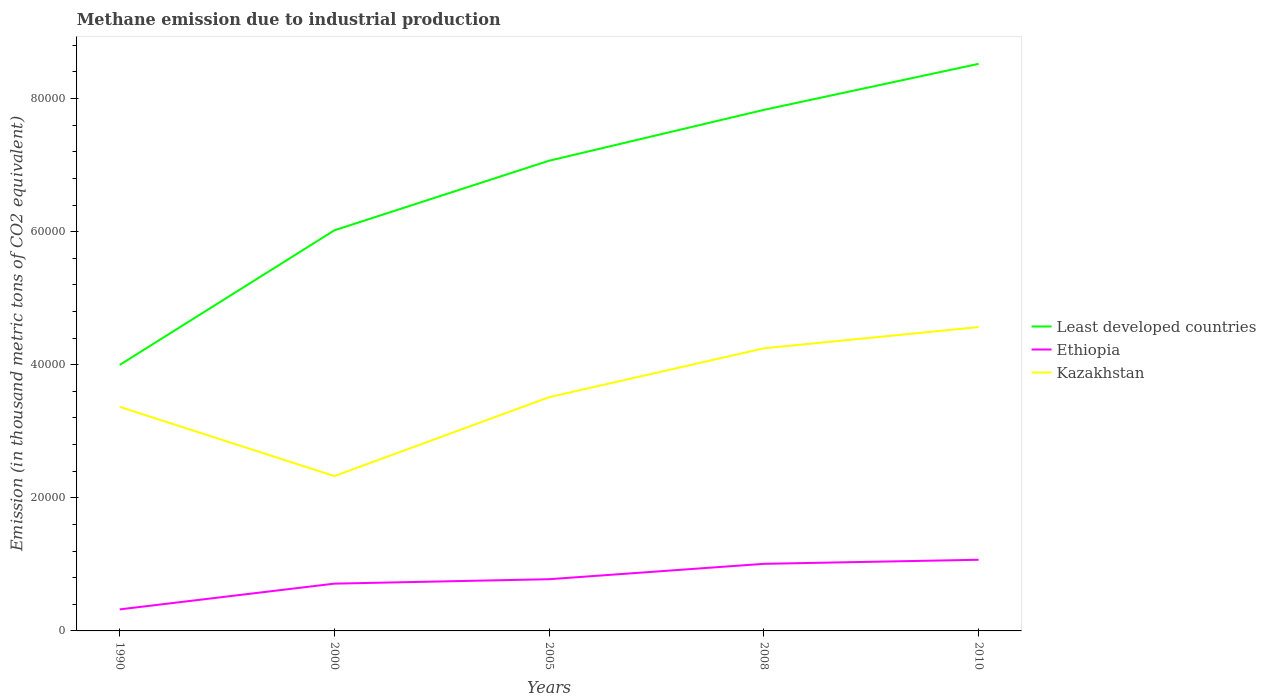How many different coloured lines are there?
Provide a succinct answer. 3. Across all years, what is the maximum amount of methane emitted in Kazakhstan?
Offer a terse response. 2.33e+04. In which year was the amount of methane emitted in Kazakhstan maximum?
Make the answer very short. 2000. What is the total amount of methane emitted in Kazakhstan in the graph?
Your response must be concise. -1456.8. What is the difference between the highest and the second highest amount of methane emitted in Least developed countries?
Provide a succinct answer. 4.52e+04. What is the difference between the highest and the lowest amount of methane emitted in Ethiopia?
Ensure brevity in your answer.  2. Are the values on the major ticks of Y-axis written in scientific E-notation?
Make the answer very short. No. Does the graph contain any zero values?
Keep it short and to the point. No. Does the graph contain grids?
Provide a succinct answer. No. How are the legend labels stacked?
Give a very brief answer. Vertical. What is the title of the graph?
Provide a succinct answer. Methane emission due to industrial production. What is the label or title of the Y-axis?
Make the answer very short. Emission (in thousand metric tons of CO2 equivalent). What is the Emission (in thousand metric tons of CO2 equivalent) of Least developed countries in 1990?
Offer a terse response. 4.00e+04. What is the Emission (in thousand metric tons of CO2 equivalent) of Ethiopia in 1990?
Give a very brief answer. 3236. What is the Emission (in thousand metric tons of CO2 equivalent) in Kazakhstan in 1990?
Provide a short and direct response. 3.37e+04. What is the Emission (in thousand metric tons of CO2 equivalent) of Least developed countries in 2000?
Provide a short and direct response. 6.02e+04. What is the Emission (in thousand metric tons of CO2 equivalent) of Ethiopia in 2000?
Ensure brevity in your answer.  7106. What is the Emission (in thousand metric tons of CO2 equivalent) of Kazakhstan in 2000?
Make the answer very short. 2.33e+04. What is the Emission (in thousand metric tons of CO2 equivalent) in Least developed countries in 2005?
Keep it short and to the point. 7.07e+04. What is the Emission (in thousand metric tons of CO2 equivalent) in Ethiopia in 2005?
Your answer should be very brief. 7772.1. What is the Emission (in thousand metric tons of CO2 equivalent) of Kazakhstan in 2005?
Your answer should be compact. 3.51e+04. What is the Emission (in thousand metric tons of CO2 equivalent) of Least developed countries in 2008?
Make the answer very short. 7.83e+04. What is the Emission (in thousand metric tons of CO2 equivalent) in Ethiopia in 2008?
Offer a terse response. 1.01e+04. What is the Emission (in thousand metric tons of CO2 equivalent) of Kazakhstan in 2008?
Offer a terse response. 4.25e+04. What is the Emission (in thousand metric tons of CO2 equivalent) of Least developed countries in 2010?
Your answer should be very brief. 8.52e+04. What is the Emission (in thousand metric tons of CO2 equivalent) of Ethiopia in 2010?
Provide a succinct answer. 1.07e+04. What is the Emission (in thousand metric tons of CO2 equivalent) of Kazakhstan in 2010?
Make the answer very short. 4.57e+04. Across all years, what is the maximum Emission (in thousand metric tons of CO2 equivalent) of Least developed countries?
Offer a very short reply. 8.52e+04. Across all years, what is the maximum Emission (in thousand metric tons of CO2 equivalent) of Ethiopia?
Offer a terse response. 1.07e+04. Across all years, what is the maximum Emission (in thousand metric tons of CO2 equivalent) in Kazakhstan?
Offer a terse response. 4.57e+04. Across all years, what is the minimum Emission (in thousand metric tons of CO2 equivalent) in Least developed countries?
Keep it short and to the point. 4.00e+04. Across all years, what is the minimum Emission (in thousand metric tons of CO2 equivalent) of Ethiopia?
Make the answer very short. 3236. Across all years, what is the minimum Emission (in thousand metric tons of CO2 equivalent) in Kazakhstan?
Offer a terse response. 2.33e+04. What is the total Emission (in thousand metric tons of CO2 equivalent) in Least developed countries in the graph?
Keep it short and to the point. 3.34e+05. What is the total Emission (in thousand metric tons of CO2 equivalent) in Ethiopia in the graph?
Keep it short and to the point. 3.89e+04. What is the total Emission (in thousand metric tons of CO2 equivalent) of Kazakhstan in the graph?
Your answer should be compact. 1.80e+05. What is the difference between the Emission (in thousand metric tons of CO2 equivalent) in Least developed countries in 1990 and that in 2000?
Your answer should be compact. -2.02e+04. What is the difference between the Emission (in thousand metric tons of CO2 equivalent) of Ethiopia in 1990 and that in 2000?
Offer a very short reply. -3870. What is the difference between the Emission (in thousand metric tons of CO2 equivalent) in Kazakhstan in 1990 and that in 2000?
Make the answer very short. 1.04e+04. What is the difference between the Emission (in thousand metric tons of CO2 equivalent) of Least developed countries in 1990 and that in 2005?
Your response must be concise. -3.07e+04. What is the difference between the Emission (in thousand metric tons of CO2 equivalent) of Ethiopia in 1990 and that in 2005?
Provide a short and direct response. -4536.1. What is the difference between the Emission (in thousand metric tons of CO2 equivalent) of Kazakhstan in 1990 and that in 2005?
Your response must be concise. -1456.8. What is the difference between the Emission (in thousand metric tons of CO2 equivalent) of Least developed countries in 1990 and that in 2008?
Give a very brief answer. -3.83e+04. What is the difference between the Emission (in thousand metric tons of CO2 equivalent) of Ethiopia in 1990 and that in 2008?
Keep it short and to the point. -6846.3. What is the difference between the Emission (in thousand metric tons of CO2 equivalent) in Kazakhstan in 1990 and that in 2008?
Offer a terse response. -8797.8. What is the difference between the Emission (in thousand metric tons of CO2 equivalent) in Least developed countries in 1990 and that in 2010?
Provide a succinct answer. -4.52e+04. What is the difference between the Emission (in thousand metric tons of CO2 equivalent) in Ethiopia in 1990 and that in 2010?
Your answer should be very brief. -7457. What is the difference between the Emission (in thousand metric tons of CO2 equivalent) in Kazakhstan in 1990 and that in 2010?
Keep it short and to the point. -1.20e+04. What is the difference between the Emission (in thousand metric tons of CO2 equivalent) in Least developed countries in 2000 and that in 2005?
Offer a terse response. -1.05e+04. What is the difference between the Emission (in thousand metric tons of CO2 equivalent) of Ethiopia in 2000 and that in 2005?
Ensure brevity in your answer.  -666.1. What is the difference between the Emission (in thousand metric tons of CO2 equivalent) in Kazakhstan in 2000 and that in 2005?
Your answer should be compact. -1.19e+04. What is the difference between the Emission (in thousand metric tons of CO2 equivalent) of Least developed countries in 2000 and that in 2008?
Your answer should be compact. -1.81e+04. What is the difference between the Emission (in thousand metric tons of CO2 equivalent) of Ethiopia in 2000 and that in 2008?
Ensure brevity in your answer.  -2976.3. What is the difference between the Emission (in thousand metric tons of CO2 equivalent) in Kazakhstan in 2000 and that in 2008?
Offer a very short reply. -1.92e+04. What is the difference between the Emission (in thousand metric tons of CO2 equivalent) in Least developed countries in 2000 and that in 2010?
Provide a short and direct response. -2.50e+04. What is the difference between the Emission (in thousand metric tons of CO2 equivalent) in Ethiopia in 2000 and that in 2010?
Provide a succinct answer. -3587. What is the difference between the Emission (in thousand metric tons of CO2 equivalent) in Kazakhstan in 2000 and that in 2010?
Offer a very short reply. -2.24e+04. What is the difference between the Emission (in thousand metric tons of CO2 equivalent) in Least developed countries in 2005 and that in 2008?
Offer a terse response. -7639.7. What is the difference between the Emission (in thousand metric tons of CO2 equivalent) in Ethiopia in 2005 and that in 2008?
Provide a succinct answer. -2310.2. What is the difference between the Emission (in thousand metric tons of CO2 equivalent) of Kazakhstan in 2005 and that in 2008?
Make the answer very short. -7341. What is the difference between the Emission (in thousand metric tons of CO2 equivalent) of Least developed countries in 2005 and that in 2010?
Your answer should be very brief. -1.46e+04. What is the difference between the Emission (in thousand metric tons of CO2 equivalent) of Ethiopia in 2005 and that in 2010?
Offer a terse response. -2920.9. What is the difference between the Emission (in thousand metric tons of CO2 equivalent) in Kazakhstan in 2005 and that in 2010?
Provide a succinct answer. -1.05e+04. What is the difference between the Emission (in thousand metric tons of CO2 equivalent) of Least developed countries in 2008 and that in 2010?
Your answer should be very brief. -6916.6. What is the difference between the Emission (in thousand metric tons of CO2 equivalent) of Ethiopia in 2008 and that in 2010?
Provide a short and direct response. -610.7. What is the difference between the Emission (in thousand metric tons of CO2 equivalent) of Kazakhstan in 2008 and that in 2010?
Your response must be concise. -3195. What is the difference between the Emission (in thousand metric tons of CO2 equivalent) of Least developed countries in 1990 and the Emission (in thousand metric tons of CO2 equivalent) of Ethiopia in 2000?
Your answer should be very brief. 3.29e+04. What is the difference between the Emission (in thousand metric tons of CO2 equivalent) of Least developed countries in 1990 and the Emission (in thousand metric tons of CO2 equivalent) of Kazakhstan in 2000?
Provide a short and direct response. 1.67e+04. What is the difference between the Emission (in thousand metric tons of CO2 equivalent) in Ethiopia in 1990 and the Emission (in thousand metric tons of CO2 equivalent) in Kazakhstan in 2000?
Offer a terse response. -2.00e+04. What is the difference between the Emission (in thousand metric tons of CO2 equivalent) of Least developed countries in 1990 and the Emission (in thousand metric tons of CO2 equivalent) of Ethiopia in 2005?
Offer a very short reply. 3.22e+04. What is the difference between the Emission (in thousand metric tons of CO2 equivalent) in Least developed countries in 1990 and the Emission (in thousand metric tons of CO2 equivalent) in Kazakhstan in 2005?
Make the answer very short. 4843.3. What is the difference between the Emission (in thousand metric tons of CO2 equivalent) of Ethiopia in 1990 and the Emission (in thousand metric tons of CO2 equivalent) of Kazakhstan in 2005?
Your answer should be very brief. -3.19e+04. What is the difference between the Emission (in thousand metric tons of CO2 equivalent) of Least developed countries in 1990 and the Emission (in thousand metric tons of CO2 equivalent) of Ethiopia in 2008?
Provide a succinct answer. 2.99e+04. What is the difference between the Emission (in thousand metric tons of CO2 equivalent) of Least developed countries in 1990 and the Emission (in thousand metric tons of CO2 equivalent) of Kazakhstan in 2008?
Provide a succinct answer. -2497.7. What is the difference between the Emission (in thousand metric tons of CO2 equivalent) of Ethiopia in 1990 and the Emission (in thousand metric tons of CO2 equivalent) of Kazakhstan in 2008?
Your answer should be very brief. -3.92e+04. What is the difference between the Emission (in thousand metric tons of CO2 equivalent) in Least developed countries in 1990 and the Emission (in thousand metric tons of CO2 equivalent) in Ethiopia in 2010?
Give a very brief answer. 2.93e+04. What is the difference between the Emission (in thousand metric tons of CO2 equivalent) in Least developed countries in 1990 and the Emission (in thousand metric tons of CO2 equivalent) in Kazakhstan in 2010?
Your response must be concise. -5692.7. What is the difference between the Emission (in thousand metric tons of CO2 equivalent) of Ethiopia in 1990 and the Emission (in thousand metric tons of CO2 equivalent) of Kazakhstan in 2010?
Your response must be concise. -4.24e+04. What is the difference between the Emission (in thousand metric tons of CO2 equivalent) in Least developed countries in 2000 and the Emission (in thousand metric tons of CO2 equivalent) in Ethiopia in 2005?
Offer a terse response. 5.24e+04. What is the difference between the Emission (in thousand metric tons of CO2 equivalent) in Least developed countries in 2000 and the Emission (in thousand metric tons of CO2 equivalent) in Kazakhstan in 2005?
Provide a short and direct response. 2.51e+04. What is the difference between the Emission (in thousand metric tons of CO2 equivalent) in Ethiopia in 2000 and the Emission (in thousand metric tons of CO2 equivalent) in Kazakhstan in 2005?
Your response must be concise. -2.80e+04. What is the difference between the Emission (in thousand metric tons of CO2 equivalent) of Least developed countries in 2000 and the Emission (in thousand metric tons of CO2 equivalent) of Ethiopia in 2008?
Your answer should be compact. 5.01e+04. What is the difference between the Emission (in thousand metric tons of CO2 equivalent) of Least developed countries in 2000 and the Emission (in thousand metric tons of CO2 equivalent) of Kazakhstan in 2008?
Keep it short and to the point. 1.77e+04. What is the difference between the Emission (in thousand metric tons of CO2 equivalent) of Ethiopia in 2000 and the Emission (in thousand metric tons of CO2 equivalent) of Kazakhstan in 2008?
Offer a terse response. -3.54e+04. What is the difference between the Emission (in thousand metric tons of CO2 equivalent) in Least developed countries in 2000 and the Emission (in thousand metric tons of CO2 equivalent) in Ethiopia in 2010?
Offer a terse response. 4.95e+04. What is the difference between the Emission (in thousand metric tons of CO2 equivalent) in Least developed countries in 2000 and the Emission (in thousand metric tons of CO2 equivalent) in Kazakhstan in 2010?
Give a very brief answer. 1.45e+04. What is the difference between the Emission (in thousand metric tons of CO2 equivalent) in Ethiopia in 2000 and the Emission (in thousand metric tons of CO2 equivalent) in Kazakhstan in 2010?
Give a very brief answer. -3.86e+04. What is the difference between the Emission (in thousand metric tons of CO2 equivalent) of Least developed countries in 2005 and the Emission (in thousand metric tons of CO2 equivalent) of Ethiopia in 2008?
Make the answer very short. 6.06e+04. What is the difference between the Emission (in thousand metric tons of CO2 equivalent) of Least developed countries in 2005 and the Emission (in thousand metric tons of CO2 equivalent) of Kazakhstan in 2008?
Offer a terse response. 2.82e+04. What is the difference between the Emission (in thousand metric tons of CO2 equivalent) of Ethiopia in 2005 and the Emission (in thousand metric tons of CO2 equivalent) of Kazakhstan in 2008?
Ensure brevity in your answer.  -3.47e+04. What is the difference between the Emission (in thousand metric tons of CO2 equivalent) of Least developed countries in 2005 and the Emission (in thousand metric tons of CO2 equivalent) of Ethiopia in 2010?
Make the answer very short. 6.00e+04. What is the difference between the Emission (in thousand metric tons of CO2 equivalent) in Least developed countries in 2005 and the Emission (in thousand metric tons of CO2 equivalent) in Kazakhstan in 2010?
Offer a very short reply. 2.50e+04. What is the difference between the Emission (in thousand metric tons of CO2 equivalent) in Ethiopia in 2005 and the Emission (in thousand metric tons of CO2 equivalent) in Kazakhstan in 2010?
Make the answer very short. -3.79e+04. What is the difference between the Emission (in thousand metric tons of CO2 equivalent) of Least developed countries in 2008 and the Emission (in thousand metric tons of CO2 equivalent) of Ethiopia in 2010?
Your response must be concise. 6.76e+04. What is the difference between the Emission (in thousand metric tons of CO2 equivalent) of Least developed countries in 2008 and the Emission (in thousand metric tons of CO2 equivalent) of Kazakhstan in 2010?
Your response must be concise. 3.26e+04. What is the difference between the Emission (in thousand metric tons of CO2 equivalent) of Ethiopia in 2008 and the Emission (in thousand metric tons of CO2 equivalent) of Kazakhstan in 2010?
Offer a terse response. -3.56e+04. What is the average Emission (in thousand metric tons of CO2 equivalent) of Least developed countries per year?
Provide a succinct answer. 6.69e+04. What is the average Emission (in thousand metric tons of CO2 equivalent) in Ethiopia per year?
Give a very brief answer. 7777.88. What is the average Emission (in thousand metric tons of CO2 equivalent) in Kazakhstan per year?
Make the answer very short. 3.60e+04. In the year 1990, what is the difference between the Emission (in thousand metric tons of CO2 equivalent) in Least developed countries and Emission (in thousand metric tons of CO2 equivalent) in Ethiopia?
Provide a short and direct response. 3.67e+04. In the year 1990, what is the difference between the Emission (in thousand metric tons of CO2 equivalent) in Least developed countries and Emission (in thousand metric tons of CO2 equivalent) in Kazakhstan?
Provide a succinct answer. 6300.1. In the year 1990, what is the difference between the Emission (in thousand metric tons of CO2 equivalent) of Ethiopia and Emission (in thousand metric tons of CO2 equivalent) of Kazakhstan?
Offer a very short reply. -3.04e+04. In the year 2000, what is the difference between the Emission (in thousand metric tons of CO2 equivalent) of Least developed countries and Emission (in thousand metric tons of CO2 equivalent) of Ethiopia?
Offer a very short reply. 5.31e+04. In the year 2000, what is the difference between the Emission (in thousand metric tons of CO2 equivalent) in Least developed countries and Emission (in thousand metric tons of CO2 equivalent) in Kazakhstan?
Your answer should be very brief. 3.69e+04. In the year 2000, what is the difference between the Emission (in thousand metric tons of CO2 equivalent) of Ethiopia and Emission (in thousand metric tons of CO2 equivalent) of Kazakhstan?
Keep it short and to the point. -1.62e+04. In the year 2005, what is the difference between the Emission (in thousand metric tons of CO2 equivalent) in Least developed countries and Emission (in thousand metric tons of CO2 equivalent) in Ethiopia?
Make the answer very short. 6.29e+04. In the year 2005, what is the difference between the Emission (in thousand metric tons of CO2 equivalent) in Least developed countries and Emission (in thousand metric tons of CO2 equivalent) in Kazakhstan?
Keep it short and to the point. 3.55e+04. In the year 2005, what is the difference between the Emission (in thousand metric tons of CO2 equivalent) in Ethiopia and Emission (in thousand metric tons of CO2 equivalent) in Kazakhstan?
Give a very brief answer. -2.74e+04. In the year 2008, what is the difference between the Emission (in thousand metric tons of CO2 equivalent) of Least developed countries and Emission (in thousand metric tons of CO2 equivalent) of Ethiopia?
Your answer should be compact. 6.82e+04. In the year 2008, what is the difference between the Emission (in thousand metric tons of CO2 equivalent) of Least developed countries and Emission (in thousand metric tons of CO2 equivalent) of Kazakhstan?
Make the answer very short. 3.58e+04. In the year 2008, what is the difference between the Emission (in thousand metric tons of CO2 equivalent) of Ethiopia and Emission (in thousand metric tons of CO2 equivalent) of Kazakhstan?
Provide a succinct answer. -3.24e+04. In the year 2010, what is the difference between the Emission (in thousand metric tons of CO2 equivalent) in Least developed countries and Emission (in thousand metric tons of CO2 equivalent) in Ethiopia?
Your answer should be compact. 7.45e+04. In the year 2010, what is the difference between the Emission (in thousand metric tons of CO2 equivalent) in Least developed countries and Emission (in thousand metric tons of CO2 equivalent) in Kazakhstan?
Your response must be concise. 3.96e+04. In the year 2010, what is the difference between the Emission (in thousand metric tons of CO2 equivalent) in Ethiopia and Emission (in thousand metric tons of CO2 equivalent) in Kazakhstan?
Keep it short and to the point. -3.50e+04. What is the ratio of the Emission (in thousand metric tons of CO2 equivalent) in Least developed countries in 1990 to that in 2000?
Your answer should be compact. 0.66. What is the ratio of the Emission (in thousand metric tons of CO2 equivalent) in Ethiopia in 1990 to that in 2000?
Ensure brevity in your answer.  0.46. What is the ratio of the Emission (in thousand metric tons of CO2 equivalent) in Kazakhstan in 1990 to that in 2000?
Offer a very short reply. 1.45. What is the ratio of the Emission (in thousand metric tons of CO2 equivalent) in Least developed countries in 1990 to that in 2005?
Keep it short and to the point. 0.57. What is the ratio of the Emission (in thousand metric tons of CO2 equivalent) in Ethiopia in 1990 to that in 2005?
Give a very brief answer. 0.42. What is the ratio of the Emission (in thousand metric tons of CO2 equivalent) in Kazakhstan in 1990 to that in 2005?
Your answer should be very brief. 0.96. What is the ratio of the Emission (in thousand metric tons of CO2 equivalent) in Least developed countries in 1990 to that in 2008?
Offer a very short reply. 0.51. What is the ratio of the Emission (in thousand metric tons of CO2 equivalent) of Ethiopia in 1990 to that in 2008?
Give a very brief answer. 0.32. What is the ratio of the Emission (in thousand metric tons of CO2 equivalent) of Kazakhstan in 1990 to that in 2008?
Your answer should be compact. 0.79. What is the ratio of the Emission (in thousand metric tons of CO2 equivalent) of Least developed countries in 1990 to that in 2010?
Give a very brief answer. 0.47. What is the ratio of the Emission (in thousand metric tons of CO2 equivalent) in Ethiopia in 1990 to that in 2010?
Your answer should be compact. 0.3. What is the ratio of the Emission (in thousand metric tons of CO2 equivalent) in Kazakhstan in 1990 to that in 2010?
Your answer should be very brief. 0.74. What is the ratio of the Emission (in thousand metric tons of CO2 equivalent) in Least developed countries in 2000 to that in 2005?
Provide a succinct answer. 0.85. What is the ratio of the Emission (in thousand metric tons of CO2 equivalent) in Ethiopia in 2000 to that in 2005?
Your response must be concise. 0.91. What is the ratio of the Emission (in thousand metric tons of CO2 equivalent) of Kazakhstan in 2000 to that in 2005?
Ensure brevity in your answer.  0.66. What is the ratio of the Emission (in thousand metric tons of CO2 equivalent) in Least developed countries in 2000 to that in 2008?
Your response must be concise. 0.77. What is the ratio of the Emission (in thousand metric tons of CO2 equivalent) in Ethiopia in 2000 to that in 2008?
Give a very brief answer. 0.7. What is the ratio of the Emission (in thousand metric tons of CO2 equivalent) of Kazakhstan in 2000 to that in 2008?
Your response must be concise. 0.55. What is the ratio of the Emission (in thousand metric tons of CO2 equivalent) in Least developed countries in 2000 to that in 2010?
Offer a very short reply. 0.71. What is the ratio of the Emission (in thousand metric tons of CO2 equivalent) in Ethiopia in 2000 to that in 2010?
Provide a succinct answer. 0.66. What is the ratio of the Emission (in thousand metric tons of CO2 equivalent) of Kazakhstan in 2000 to that in 2010?
Offer a terse response. 0.51. What is the ratio of the Emission (in thousand metric tons of CO2 equivalent) in Least developed countries in 2005 to that in 2008?
Your answer should be compact. 0.9. What is the ratio of the Emission (in thousand metric tons of CO2 equivalent) of Ethiopia in 2005 to that in 2008?
Provide a short and direct response. 0.77. What is the ratio of the Emission (in thousand metric tons of CO2 equivalent) of Kazakhstan in 2005 to that in 2008?
Provide a short and direct response. 0.83. What is the ratio of the Emission (in thousand metric tons of CO2 equivalent) of Least developed countries in 2005 to that in 2010?
Offer a terse response. 0.83. What is the ratio of the Emission (in thousand metric tons of CO2 equivalent) in Ethiopia in 2005 to that in 2010?
Offer a very short reply. 0.73. What is the ratio of the Emission (in thousand metric tons of CO2 equivalent) in Kazakhstan in 2005 to that in 2010?
Make the answer very short. 0.77. What is the ratio of the Emission (in thousand metric tons of CO2 equivalent) of Least developed countries in 2008 to that in 2010?
Give a very brief answer. 0.92. What is the ratio of the Emission (in thousand metric tons of CO2 equivalent) of Ethiopia in 2008 to that in 2010?
Your answer should be very brief. 0.94. What is the ratio of the Emission (in thousand metric tons of CO2 equivalent) of Kazakhstan in 2008 to that in 2010?
Keep it short and to the point. 0.93. What is the difference between the highest and the second highest Emission (in thousand metric tons of CO2 equivalent) in Least developed countries?
Provide a succinct answer. 6916.6. What is the difference between the highest and the second highest Emission (in thousand metric tons of CO2 equivalent) in Ethiopia?
Keep it short and to the point. 610.7. What is the difference between the highest and the second highest Emission (in thousand metric tons of CO2 equivalent) of Kazakhstan?
Your answer should be very brief. 3195. What is the difference between the highest and the lowest Emission (in thousand metric tons of CO2 equivalent) in Least developed countries?
Your answer should be very brief. 4.52e+04. What is the difference between the highest and the lowest Emission (in thousand metric tons of CO2 equivalent) in Ethiopia?
Your answer should be very brief. 7457. What is the difference between the highest and the lowest Emission (in thousand metric tons of CO2 equivalent) in Kazakhstan?
Ensure brevity in your answer.  2.24e+04. 